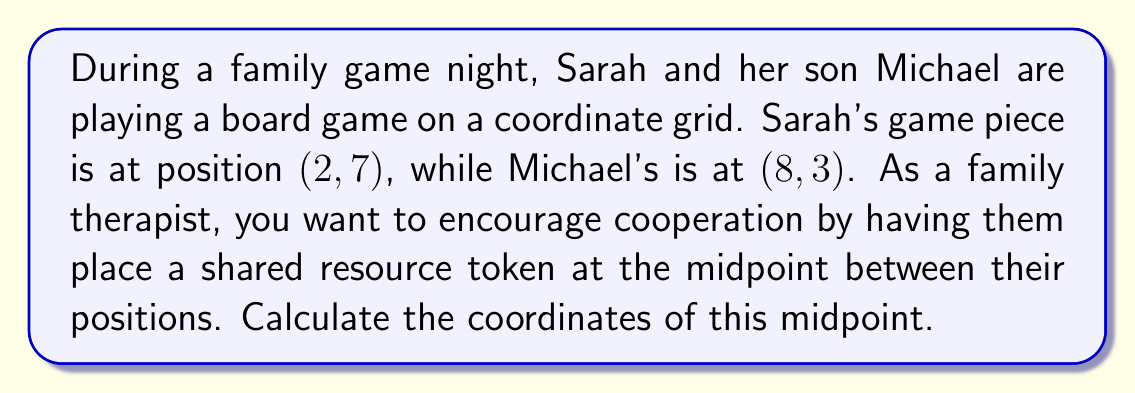Solve this math problem. To find the midpoint between two points on a coordinate plane, we use the midpoint formula:

$$ \text{Midpoint} = \left(\frac{x_1 + x_2}{2}, \frac{y_1 + y_2}{2}\right) $$

Where $(x_1, y_1)$ is the first point and $(x_2, y_2)$ is the second point.

In this case:
- Sarah's position: $(x_1, y_1) = (2, 7)$
- Michael's position: $(x_2, y_2) = (8, 3)$

Let's calculate the x-coordinate of the midpoint:

$$ x_{\text{midpoint}} = \frac{x_1 + x_2}{2} = \frac{2 + 8}{2} = \frac{10}{2} = 5 $$

Now, let's calculate the y-coordinate of the midpoint:

$$ y_{\text{midpoint}} = \frac{y_1 + y_2}{2} = \frac{7 + 3}{2} = \frac{10}{2} = 5 $$

Therefore, the midpoint coordinates are $(5, 5)$.

[asy]
unitsize(1cm);
defaultpen(fontsize(10pt));
grid(10,10,gray(0.7));
dot((2,7),red);
dot((8,3),blue);
dot((5,5),green);
label("Sarah (2,7)", (2,7), NE, red);
label("Michael (8,3)", (8,3), SE, blue);
label("Midpoint (5,5)", (5,5), N, green);
draw((2,7)--(8,3),dashed);
axes(Label("x"), Label("y"), (0,0), (10,10), Arrow);
[/asy]
Answer: The coordinates of the midpoint are $(5, 5)$. 